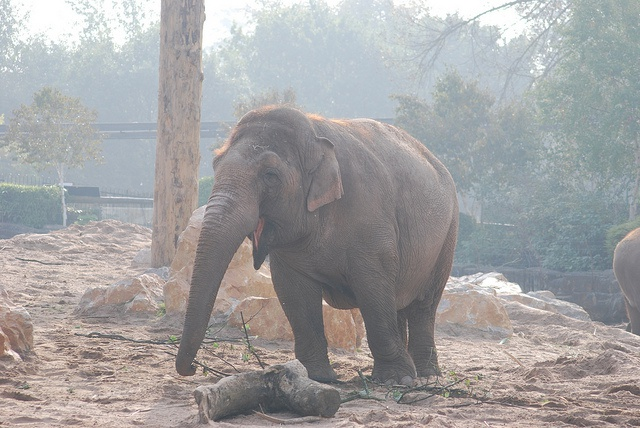Describe the objects in this image and their specific colors. I can see elephant in white, gray, and darkgray tones and elephant in white, gray, and tan tones in this image. 